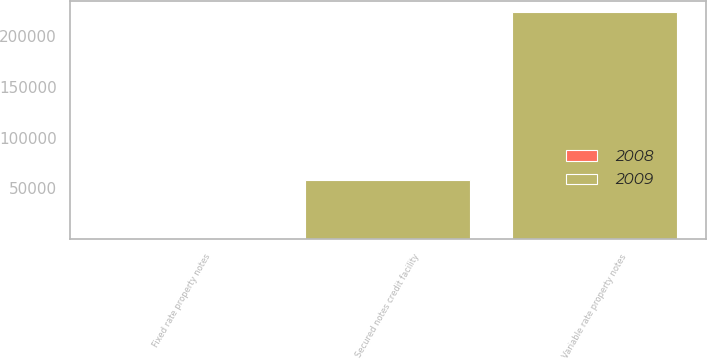Convert chart to OTSL. <chart><loc_0><loc_0><loc_500><loc_500><stacked_bar_chart><ecel><fcel>Fixed rate property notes<fcel>Variable rate property notes<fcel>Secured notes credit facility<nl><fcel>2008<fcel>6.01<fcel>2.46<fcel>1.02<nl><fcel>2009<fcel>6.01<fcel>223561<fcel>58179<nl></chart> 